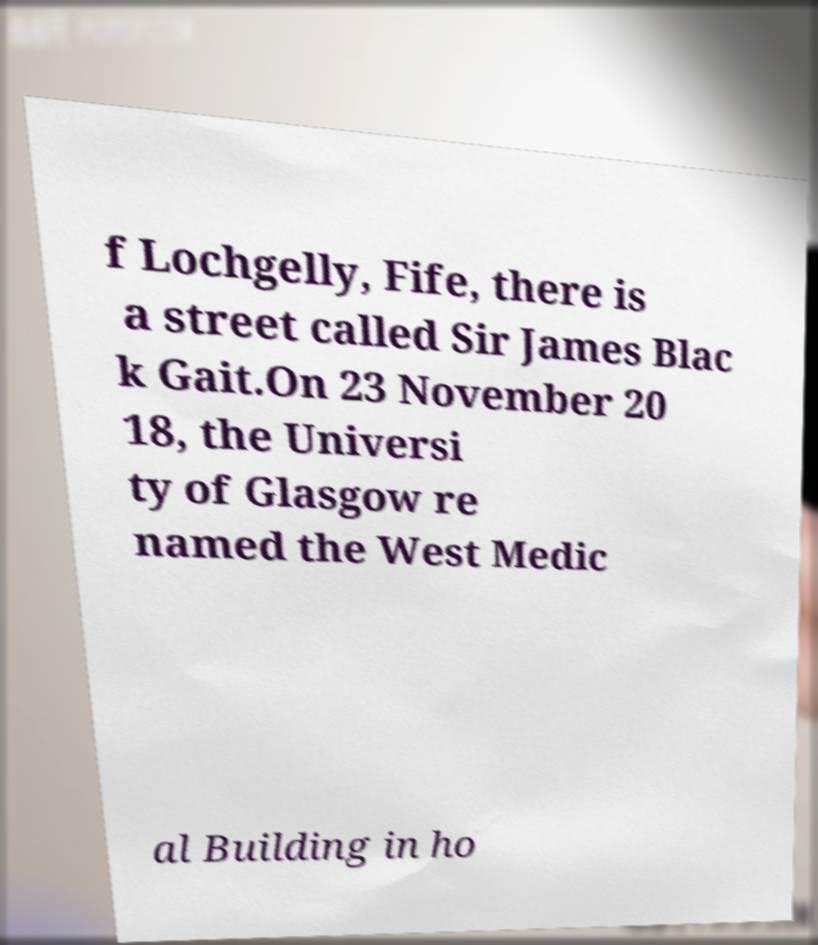Can you accurately transcribe the text from the provided image for me? f Lochgelly, Fife, there is a street called Sir James Blac k Gait.On 23 November 20 18, the Universi ty of Glasgow re named the West Medic al Building in ho 